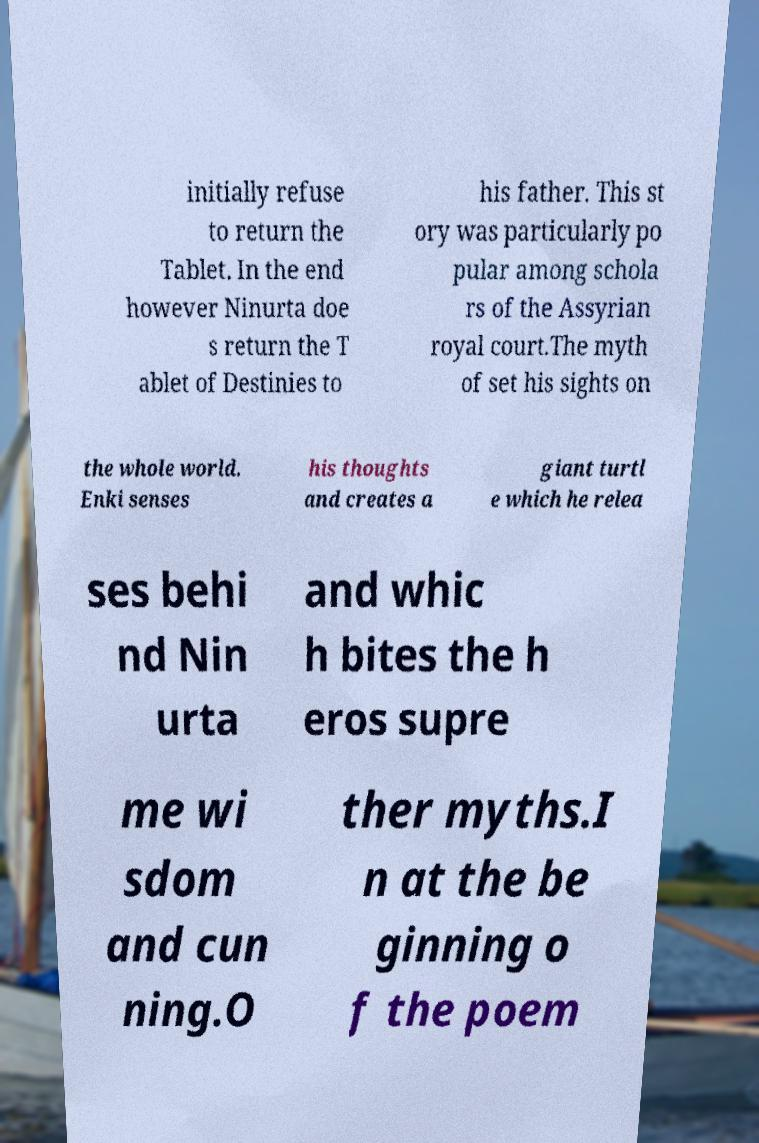For documentation purposes, I need the text within this image transcribed. Could you provide that? initially refuse to return the Tablet. In the end however Ninurta doe s return the T ablet of Destinies to his father. This st ory was particularly po pular among schola rs of the Assyrian royal court.The myth of set his sights on the whole world. Enki senses his thoughts and creates a giant turtl e which he relea ses behi nd Nin urta and whic h bites the h eros supre me wi sdom and cun ning.O ther myths.I n at the be ginning o f the poem 